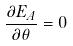Convert formula to latex. <formula><loc_0><loc_0><loc_500><loc_500>\frac { \partial E _ { A } } { \partial \theta } = 0</formula> 